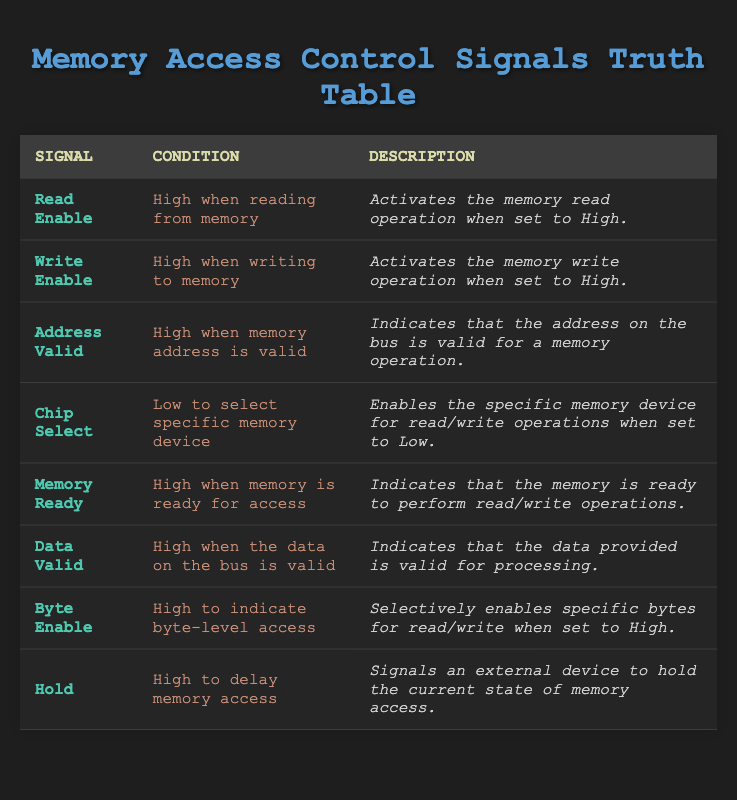What is the condition for the "Read Enable" signal? The table shows that the condition for the "Read Enable" signal is "High when reading from memory." This is directly stated in the second column of the corresponding row.
Answer: High when reading from memory Which signal activates the memory write operation? From the table, the signal that activates the memory write operation is the "Write Enable" signal. This is located in the first column, and its corresponding description confirms its purpose.
Answer: Write Enable Is the "Chip Select" signal high or low when selecting a specific memory device? The table indicates that the "Chip Select" signal is "Low to select specific memory device." Therefore, the signal is low in this scenario, as shown in the second column of its row.
Answer: Low What is the primary function of the "Memory Ready" signal? According to the table, the "Memory Ready" signal indicates that the memory is ready for access when it is high. This explanation is provided in the description section of its row, clarifying its role in memory operations.
Answer: Indicates readiness for access Which signals are associated with data validity? To find signals associated with data validity, we look for conditions related to valid data. The table shows "Data Valid" as a specific signal that indicates data is valid when high. Additionally, "Address Valid" indicates that the address is valid when high. This means both signals relate to validity processes.
Answer: Data Valid and Address Valid How many signals mentioned in the table require a "High" condition? We can count the signals that have "High" in their conditions. The signals are "Read Enable," "Write Enable," "Address Valid," "Memory Ready," "Data Valid," "Byte Enable," and "Hold." This totals 6 signals requiring a "High" condition specified in the conditions column.
Answer: 6 Is the "Hold" signal responsible for initiating or delaying memory access? The table specifies that the "Hold" signal is "High to delay memory access." Therefore, this means its purpose is to delay access rather than initiate it.
Answer: Delaying memory access What happens when the "Chip Select" signal is set low? The table states that when the "Chip Select" signal is low, it enables the specific memory device for read/write operations. Thus, the action of enabling occurs when this signal is low.
Answer: Enables specific memory device Does the "Byte Enable" signal control access at byte-level granularity? According to the table, the "Byte Enable" signal is described as being "High to indicate byte-level access," which confirms that it indeed controls access at the byte level.
Answer: Yes, it controls byte-level access 